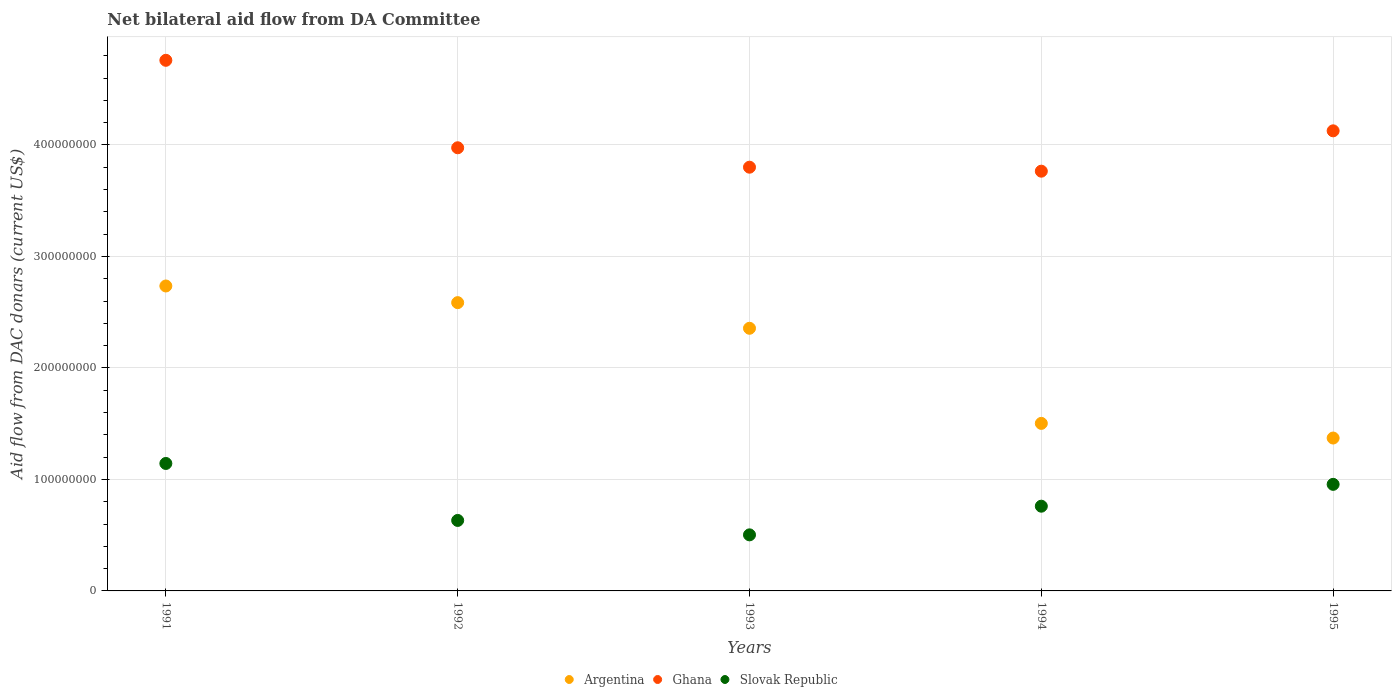What is the aid flow in in Slovak Republic in 1995?
Offer a terse response. 9.56e+07. Across all years, what is the maximum aid flow in in Argentina?
Offer a terse response. 2.74e+08. Across all years, what is the minimum aid flow in in Slovak Republic?
Give a very brief answer. 5.03e+07. In which year was the aid flow in in Ghana minimum?
Offer a very short reply. 1994. What is the total aid flow in in Ghana in the graph?
Give a very brief answer. 2.04e+09. What is the difference between the aid flow in in Argentina in 1991 and that in 1992?
Give a very brief answer. 1.49e+07. What is the difference between the aid flow in in Slovak Republic in 1991 and the aid flow in in Ghana in 1995?
Your response must be concise. -2.98e+08. What is the average aid flow in in Slovak Republic per year?
Offer a terse response. 7.99e+07. In the year 1991, what is the difference between the aid flow in in Ghana and aid flow in in Argentina?
Your response must be concise. 2.02e+08. In how many years, is the aid flow in in Ghana greater than 80000000 US$?
Ensure brevity in your answer.  5. What is the ratio of the aid flow in in Ghana in 1994 to that in 1995?
Your answer should be very brief. 0.91. Is the aid flow in in Argentina in 1993 less than that in 1995?
Offer a terse response. No. Is the difference between the aid flow in in Ghana in 1992 and 1995 greater than the difference between the aid flow in in Argentina in 1992 and 1995?
Ensure brevity in your answer.  No. What is the difference between the highest and the second highest aid flow in in Ghana?
Provide a succinct answer. 6.33e+07. What is the difference between the highest and the lowest aid flow in in Ghana?
Offer a very short reply. 9.94e+07. In how many years, is the aid flow in in Slovak Republic greater than the average aid flow in in Slovak Republic taken over all years?
Your answer should be very brief. 2. Is the sum of the aid flow in in Slovak Republic in 1991 and 1995 greater than the maximum aid flow in in Ghana across all years?
Make the answer very short. No. Is it the case that in every year, the sum of the aid flow in in Argentina and aid flow in in Ghana  is greater than the aid flow in in Slovak Republic?
Your answer should be compact. Yes. Does the aid flow in in Argentina monotonically increase over the years?
Make the answer very short. No. Is the aid flow in in Argentina strictly greater than the aid flow in in Ghana over the years?
Your response must be concise. No. Are the values on the major ticks of Y-axis written in scientific E-notation?
Make the answer very short. No. Does the graph contain any zero values?
Your response must be concise. No. How many legend labels are there?
Your answer should be very brief. 3. How are the legend labels stacked?
Your answer should be very brief. Horizontal. What is the title of the graph?
Offer a very short reply. Net bilateral aid flow from DA Committee. Does "Lithuania" appear as one of the legend labels in the graph?
Keep it short and to the point. No. What is the label or title of the Y-axis?
Provide a succinct answer. Aid flow from DAC donars (current US$). What is the Aid flow from DAC donars (current US$) of Argentina in 1991?
Make the answer very short. 2.74e+08. What is the Aid flow from DAC donars (current US$) in Ghana in 1991?
Your response must be concise. 4.76e+08. What is the Aid flow from DAC donars (current US$) of Slovak Republic in 1991?
Give a very brief answer. 1.14e+08. What is the Aid flow from DAC donars (current US$) in Argentina in 1992?
Your answer should be very brief. 2.59e+08. What is the Aid flow from DAC donars (current US$) of Ghana in 1992?
Your answer should be very brief. 3.97e+08. What is the Aid flow from DAC donars (current US$) in Slovak Republic in 1992?
Your response must be concise. 6.32e+07. What is the Aid flow from DAC donars (current US$) in Argentina in 1993?
Ensure brevity in your answer.  2.36e+08. What is the Aid flow from DAC donars (current US$) in Ghana in 1993?
Offer a terse response. 3.80e+08. What is the Aid flow from DAC donars (current US$) in Slovak Republic in 1993?
Ensure brevity in your answer.  5.03e+07. What is the Aid flow from DAC donars (current US$) of Argentina in 1994?
Provide a short and direct response. 1.50e+08. What is the Aid flow from DAC donars (current US$) in Ghana in 1994?
Your response must be concise. 3.76e+08. What is the Aid flow from DAC donars (current US$) of Slovak Republic in 1994?
Provide a short and direct response. 7.60e+07. What is the Aid flow from DAC donars (current US$) in Argentina in 1995?
Offer a very short reply. 1.37e+08. What is the Aid flow from DAC donars (current US$) of Ghana in 1995?
Make the answer very short. 4.13e+08. What is the Aid flow from DAC donars (current US$) of Slovak Republic in 1995?
Your response must be concise. 9.56e+07. Across all years, what is the maximum Aid flow from DAC donars (current US$) of Argentina?
Ensure brevity in your answer.  2.74e+08. Across all years, what is the maximum Aid flow from DAC donars (current US$) of Ghana?
Keep it short and to the point. 4.76e+08. Across all years, what is the maximum Aid flow from DAC donars (current US$) in Slovak Republic?
Ensure brevity in your answer.  1.14e+08. Across all years, what is the minimum Aid flow from DAC donars (current US$) in Argentina?
Ensure brevity in your answer.  1.37e+08. Across all years, what is the minimum Aid flow from DAC donars (current US$) in Ghana?
Provide a succinct answer. 3.76e+08. Across all years, what is the minimum Aid flow from DAC donars (current US$) in Slovak Republic?
Keep it short and to the point. 5.03e+07. What is the total Aid flow from DAC donars (current US$) of Argentina in the graph?
Your response must be concise. 1.06e+09. What is the total Aid flow from DAC donars (current US$) in Ghana in the graph?
Provide a short and direct response. 2.04e+09. What is the total Aid flow from DAC donars (current US$) of Slovak Republic in the graph?
Your response must be concise. 3.99e+08. What is the difference between the Aid flow from DAC donars (current US$) of Argentina in 1991 and that in 1992?
Make the answer very short. 1.49e+07. What is the difference between the Aid flow from DAC donars (current US$) of Ghana in 1991 and that in 1992?
Provide a short and direct response. 7.84e+07. What is the difference between the Aid flow from DAC donars (current US$) of Slovak Republic in 1991 and that in 1992?
Provide a succinct answer. 5.11e+07. What is the difference between the Aid flow from DAC donars (current US$) in Argentina in 1991 and that in 1993?
Offer a terse response. 3.79e+07. What is the difference between the Aid flow from DAC donars (current US$) of Ghana in 1991 and that in 1993?
Offer a terse response. 9.59e+07. What is the difference between the Aid flow from DAC donars (current US$) of Slovak Republic in 1991 and that in 1993?
Give a very brief answer. 6.40e+07. What is the difference between the Aid flow from DAC donars (current US$) of Argentina in 1991 and that in 1994?
Provide a succinct answer. 1.23e+08. What is the difference between the Aid flow from DAC donars (current US$) in Ghana in 1991 and that in 1994?
Your answer should be very brief. 9.94e+07. What is the difference between the Aid flow from DAC donars (current US$) in Slovak Republic in 1991 and that in 1994?
Your response must be concise. 3.83e+07. What is the difference between the Aid flow from DAC donars (current US$) in Argentina in 1991 and that in 1995?
Provide a succinct answer. 1.36e+08. What is the difference between the Aid flow from DAC donars (current US$) of Ghana in 1991 and that in 1995?
Offer a terse response. 6.33e+07. What is the difference between the Aid flow from DAC donars (current US$) of Slovak Republic in 1991 and that in 1995?
Offer a terse response. 1.87e+07. What is the difference between the Aid flow from DAC donars (current US$) of Argentina in 1992 and that in 1993?
Ensure brevity in your answer.  2.30e+07. What is the difference between the Aid flow from DAC donars (current US$) in Ghana in 1992 and that in 1993?
Provide a short and direct response. 1.74e+07. What is the difference between the Aid flow from DAC donars (current US$) in Slovak Republic in 1992 and that in 1993?
Offer a very short reply. 1.29e+07. What is the difference between the Aid flow from DAC donars (current US$) of Argentina in 1992 and that in 1994?
Offer a very short reply. 1.08e+08. What is the difference between the Aid flow from DAC donars (current US$) in Ghana in 1992 and that in 1994?
Provide a succinct answer. 2.10e+07. What is the difference between the Aid flow from DAC donars (current US$) of Slovak Republic in 1992 and that in 1994?
Give a very brief answer. -1.28e+07. What is the difference between the Aid flow from DAC donars (current US$) of Argentina in 1992 and that in 1995?
Give a very brief answer. 1.21e+08. What is the difference between the Aid flow from DAC donars (current US$) of Ghana in 1992 and that in 1995?
Ensure brevity in your answer.  -1.52e+07. What is the difference between the Aid flow from DAC donars (current US$) in Slovak Republic in 1992 and that in 1995?
Make the answer very short. -3.24e+07. What is the difference between the Aid flow from DAC donars (current US$) of Argentina in 1993 and that in 1994?
Ensure brevity in your answer.  8.53e+07. What is the difference between the Aid flow from DAC donars (current US$) in Ghana in 1993 and that in 1994?
Offer a very short reply. 3.57e+06. What is the difference between the Aid flow from DAC donars (current US$) of Slovak Republic in 1993 and that in 1994?
Your answer should be compact. -2.57e+07. What is the difference between the Aid flow from DAC donars (current US$) in Argentina in 1993 and that in 1995?
Offer a terse response. 9.84e+07. What is the difference between the Aid flow from DAC donars (current US$) of Ghana in 1993 and that in 1995?
Your answer should be compact. -3.26e+07. What is the difference between the Aid flow from DAC donars (current US$) of Slovak Republic in 1993 and that in 1995?
Keep it short and to the point. -4.53e+07. What is the difference between the Aid flow from DAC donars (current US$) in Argentina in 1994 and that in 1995?
Provide a short and direct response. 1.31e+07. What is the difference between the Aid flow from DAC donars (current US$) in Ghana in 1994 and that in 1995?
Make the answer very short. -3.62e+07. What is the difference between the Aid flow from DAC donars (current US$) in Slovak Republic in 1994 and that in 1995?
Your answer should be very brief. -1.96e+07. What is the difference between the Aid flow from DAC donars (current US$) in Argentina in 1991 and the Aid flow from DAC donars (current US$) in Ghana in 1992?
Provide a succinct answer. -1.24e+08. What is the difference between the Aid flow from DAC donars (current US$) in Argentina in 1991 and the Aid flow from DAC donars (current US$) in Slovak Republic in 1992?
Your answer should be compact. 2.10e+08. What is the difference between the Aid flow from DAC donars (current US$) of Ghana in 1991 and the Aid flow from DAC donars (current US$) of Slovak Republic in 1992?
Your answer should be very brief. 4.13e+08. What is the difference between the Aid flow from DAC donars (current US$) of Argentina in 1991 and the Aid flow from DAC donars (current US$) of Ghana in 1993?
Give a very brief answer. -1.07e+08. What is the difference between the Aid flow from DAC donars (current US$) of Argentina in 1991 and the Aid flow from DAC donars (current US$) of Slovak Republic in 1993?
Provide a short and direct response. 2.23e+08. What is the difference between the Aid flow from DAC donars (current US$) of Ghana in 1991 and the Aid flow from DAC donars (current US$) of Slovak Republic in 1993?
Your answer should be very brief. 4.26e+08. What is the difference between the Aid flow from DAC donars (current US$) in Argentina in 1991 and the Aid flow from DAC donars (current US$) in Ghana in 1994?
Ensure brevity in your answer.  -1.03e+08. What is the difference between the Aid flow from DAC donars (current US$) in Argentina in 1991 and the Aid flow from DAC donars (current US$) in Slovak Republic in 1994?
Give a very brief answer. 1.98e+08. What is the difference between the Aid flow from DAC donars (current US$) in Ghana in 1991 and the Aid flow from DAC donars (current US$) in Slovak Republic in 1994?
Keep it short and to the point. 4.00e+08. What is the difference between the Aid flow from DAC donars (current US$) in Argentina in 1991 and the Aid flow from DAC donars (current US$) in Ghana in 1995?
Your answer should be compact. -1.39e+08. What is the difference between the Aid flow from DAC donars (current US$) of Argentina in 1991 and the Aid flow from DAC donars (current US$) of Slovak Republic in 1995?
Your answer should be very brief. 1.78e+08. What is the difference between the Aid flow from DAC donars (current US$) of Ghana in 1991 and the Aid flow from DAC donars (current US$) of Slovak Republic in 1995?
Your answer should be compact. 3.80e+08. What is the difference between the Aid flow from DAC donars (current US$) of Argentina in 1992 and the Aid flow from DAC donars (current US$) of Ghana in 1993?
Your answer should be compact. -1.21e+08. What is the difference between the Aid flow from DAC donars (current US$) in Argentina in 1992 and the Aid flow from DAC donars (current US$) in Slovak Republic in 1993?
Your answer should be compact. 2.08e+08. What is the difference between the Aid flow from DAC donars (current US$) of Ghana in 1992 and the Aid flow from DAC donars (current US$) of Slovak Republic in 1993?
Offer a terse response. 3.47e+08. What is the difference between the Aid flow from DAC donars (current US$) of Argentina in 1992 and the Aid flow from DAC donars (current US$) of Ghana in 1994?
Provide a short and direct response. -1.18e+08. What is the difference between the Aid flow from DAC donars (current US$) of Argentina in 1992 and the Aid flow from DAC donars (current US$) of Slovak Republic in 1994?
Your answer should be compact. 1.83e+08. What is the difference between the Aid flow from DAC donars (current US$) in Ghana in 1992 and the Aid flow from DAC donars (current US$) in Slovak Republic in 1994?
Your answer should be very brief. 3.21e+08. What is the difference between the Aid flow from DAC donars (current US$) in Argentina in 1992 and the Aid flow from DAC donars (current US$) in Ghana in 1995?
Offer a very short reply. -1.54e+08. What is the difference between the Aid flow from DAC donars (current US$) in Argentina in 1992 and the Aid flow from DAC donars (current US$) in Slovak Republic in 1995?
Your answer should be very brief. 1.63e+08. What is the difference between the Aid flow from DAC donars (current US$) of Ghana in 1992 and the Aid flow from DAC donars (current US$) of Slovak Republic in 1995?
Offer a terse response. 3.02e+08. What is the difference between the Aid flow from DAC donars (current US$) of Argentina in 1993 and the Aid flow from DAC donars (current US$) of Ghana in 1994?
Ensure brevity in your answer.  -1.41e+08. What is the difference between the Aid flow from DAC donars (current US$) of Argentina in 1993 and the Aid flow from DAC donars (current US$) of Slovak Republic in 1994?
Your answer should be compact. 1.60e+08. What is the difference between the Aid flow from DAC donars (current US$) of Ghana in 1993 and the Aid flow from DAC donars (current US$) of Slovak Republic in 1994?
Keep it short and to the point. 3.04e+08. What is the difference between the Aid flow from DAC donars (current US$) of Argentina in 1993 and the Aid flow from DAC donars (current US$) of Ghana in 1995?
Offer a terse response. -1.77e+08. What is the difference between the Aid flow from DAC donars (current US$) of Argentina in 1993 and the Aid flow from DAC donars (current US$) of Slovak Republic in 1995?
Provide a succinct answer. 1.40e+08. What is the difference between the Aid flow from DAC donars (current US$) in Ghana in 1993 and the Aid flow from DAC donars (current US$) in Slovak Republic in 1995?
Offer a very short reply. 2.84e+08. What is the difference between the Aid flow from DAC donars (current US$) in Argentina in 1994 and the Aid flow from DAC donars (current US$) in Ghana in 1995?
Your answer should be compact. -2.62e+08. What is the difference between the Aid flow from DAC donars (current US$) of Argentina in 1994 and the Aid flow from DAC donars (current US$) of Slovak Republic in 1995?
Ensure brevity in your answer.  5.47e+07. What is the difference between the Aid flow from DAC donars (current US$) of Ghana in 1994 and the Aid flow from DAC donars (current US$) of Slovak Republic in 1995?
Keep it short and to the point. 2.81e+08. What is the average Aid flow from DAC donars (current US$) in Argentina per year?
Give a very brief answer. 2.11e+08. What is the average Aid flow from DAC donars (current US$) of Ghana per year?
Offer a very short reply. 4.09e+08. What is the average Aid flow from DAC donars (current US$) in Slovak Republic per year?
Make the answer very short. 7.99e+07. In the year 1991, what is the difference between the Aid flow from DAC donars (current US$) of Argentina and Aid flow from DAC donars (current US$) of Ghana?
Offer a very short reply. -2.02e+08. In the year 1991, what is the difference between the Aid flow from DAC donars (current US$) of Argentina and Aid flow from DAC donars (current US$) of Slovak Republic?
Your response must be concise. 1.59e+08. In the year 1991, what is the difference between the Aid flow from DAC donars (current US$) in Ghana and Aid flow from DAC donars (current US$) in Slovak Republic?
Make the answer very short. 3.62e+08. In the year 1992, what is the difference between the Aid flow from DAC donars (current US$) of Argentina and Aid flow from DAC donars (current US$) of Ghana?
Provide a short and direct response. -1.39e+08. In the year 1992, what is the difference between the Aid flow from DAC donars (current US$) of Argentina and Aid flow from DAC donars (current US$) of Slovak Republic?
Give a very brief answer. 1.95e+08. In the year 1992, what is the difference between the Aid flow from DAC donars (current US$) of Ghana and Aid flow from DAC donars (current US$) of Slovak Republic?
Offer a terse response. 3.34e+08. In the year 1993, what is the difference between the Aid flow from DAC donars (current US$) of Argentina and Aid flow from DAC donars (current US$) of Ghana?
Provide a succinct answer. -1.44e+08. In the year 1993, what is the difference between the Aid flow from DAC donars (current US$) of Argentina and Aid flow from DAC donars (current US$) of Slovak Republic?
Ensure brevity in your answer.  1.85e+08. In the year 1993, what is the difference between the Aid flow from DAC donars (current US$) of Ghana and Aid flow from DAC donars (current US$) of Slovak Republic?
Your answer should be very brief. 3.30e+08. In the year 1994, what is the difference between the Aid flow from DAC donars (current US$) in Argentina and Aid flow from DAC donars (current US$) in Ghana?
Make the answer very short. -2.26e+08. In the year 1994, what is the difference between the Aid flow from DAC donars (current US$) in Argentina and Aid flow from DAC donars (current US$) in Slovak Republic?
Your answer should be very brief. 7.43e+07. In the year 1994, what is the difference between the Aid flow from DAC donars (current US$) of Ghana and Aid flow from DAC donars (current US$) of Slovak Republic?
Make the answer very short. 3.00e+08. In the year 1995, what is the difference between the Aid flow from DAC donars (current US$) in Argentina and Aid flow from DAC donars (current US$) in Ghana?
Keep it short and to the point. -2.76e+08. In the year 1995, what is the difference between the Aid flow from DAC donars (current US$) in Argentina and Aid flow from DAC donars (current US$) in Slovak Republic?
Offer a very short reply. 4.15e+07. In the year 1995, what is the difference between the Aid flow from DAC donars (current US$) of Ghana and Aid flow from DAC donars (current US$) of Slovak Republic?
Make the answer very short. 3.17e+08. What is the ratio of the Aid flow from DAC donars (current US$) of Argentina in 1991 to that in 1992?
Give a very brief answer. 1.06. What is the ratio of the Aid flow from DAC donars (current US$) in Ghana in 1991 to that in 1992?
Offer a terse response. 1.2. What is the ratio of the Aid flow from DAC donars (current US$) in Slovak Republic in 1991 to that in 1992?
Give a very brief answer. 1.81. What is the ratio of the Aid flow from DAC donars (current US$) in Argentina in 1991 to that in 1993?
Ensure brevity in your answer.  1.16. What is the ratio of the Aid flow from DAC donars (current US$) in Ghana in 1991 to that in 1993?
Provide a short and direct response. 1.25. What is the ratio of the Aid flow from DAC donars (current US$) of Slovak Republic in 1991 to that in 1993?
Give a very brief answer. 2.27. What is the ratio of the Aid flow from DAC donars (current US$) of Argentina in 1991 to that in 1994?
Offer a terse response. 1.82. What is the ratio of the Aid flow from DAC donars (current US$) in Ghana in 1991 to that in 1994?
Offer a terse response. 1.26. What is the ratio of the Aid flow from DAC donars (current US$) in Slovak Republic in 1991 to that in 1994?
Provide a short and direct response. 1.5. What is the ratio of the Aid flow from DAC donars (current US$) in Argentina in 1991 to that in 1995?
Offer a terse response. 1.99. What is the ratio of the Aid flow from DAC donars (current US$) in Ghana in 1991 to that in 1995?
Make the answer very short. 1.15. What is the ratio of the Aid flow from DAC donars (current US$) in Slovak Republic in 1991 to that in 1995?
Provide a succinct answer. 1.2. What is the ratio of the Aid flow from DAC donars (current US$) in Argentina in 1992 to that in 1993?
Offer a very short reply. 1.1. What is the ratio of the Aid flow from DAC donars (current US$) of Ghana in 1992 to that in 1993?
Your answer should be compact. 1.05. What is the ratio of the Aid flow from DAC donars (current US$) in Slovak Republic in 1992 to that in 1993?
Provide a short and direct response. 1.26. What is the ratio of the Aid flow from DAC donars (current US$) of Argentina in 1992 to that in 1994?
Your answer should be compact. 1.72. What is the ratio of the Aid flow from DAC donars (current US$) in Ghana in 1992 to that in 1994?
Your response must be concise. 1.06. What is the ratio of the Aid flow from DAC donars (current US$) in Slovak Republic in 1992 to that in 1994?
Provide a short and direct response. 0.83. What is the ratio of the Aid flow from DAC donars (current US$) of Argentina in 1992 to that in 1995?
Your answer should be very brief. 1.89. What is the ratio of the Aid flow from DAC donars (current US$) of Ghana in 1992 to that in 1995?
Give a very brief answer. 0.96. What is the ratio of the Aid flow from DAC donars (current US$) in Slovak Republic in 1992 to that in 1995?
Provide a short and direct response. 0.66. What is the ratio of the Aid flow from DAC donars (current US$) in Argentina in 1993 to that in 1994?
Your response must be concise. 1.57. What is the ratio of the Aid flow from DAC donars (current US$) of Ghana in 1993 to that in 1994?
Offer a terse response. 1.01. What is the ratio of the Aid flow from DAC donars (current US$) of Slovak Republic in 1993 to that in 1994?
Your answer should be compact. 0.66. What is the ratio of the Aid flow from DAC donars (current US$) in Argentina in 1993 to that in 1995?
Your answer should be compact. 1.72. What is the ratio of the Aid flow from DAC donars (current US$) of Ghana in 1993 to that in 1995?
Provide a succinct answer. 0.92. What is the ratio of the Aid flow from DAC donars (current US$) in Slovak Republic in 1993 to that in 1995?
Give a very brief answer. 0.53. What is the ratio of the Aid flow from DAC donars (current US$) in Argentina in 1994 to that in 1995?
Make the answer very short. 1.1. What is the ratio of the Aid flow from DAC donars (current US$) of Ghana in 1994 to that in 1995?
Make the answer very short. 0.91. What is the ratio of the Aid flow from DAC donars (current US$) of Slovak Republic in 1994 to that in 1995?
Your response must be concise. 0.8. What is the difference between the highest and the second highest Aid flow from DAC donars (current US$) in Argentina?
Make the answer very short. 1.49e+07. What is the difference between the highest and the second highest Aid flow from DAC donars (current US$) of Ghana?
Keep it short and to the point. 6.33e+07. What is the difference between the highest and the second highest Aid flow from DAC donars (current US$) of Slovak Republic?
Your response must be concise. 1.87e+07. What is the difference between the highest and the lowest Aid flow from DAC donars (current US$) of Argentina?
Your answer should be compact. 1.36e+08. What is the difference between the highest and the lowest Aid flow from DAC donars (current US$) in Ghana?
Your response must be concise. 9.94e+07. What is the difference between the highest and the lowest Aid flow from DAC donars (current US$) in Slovak Republic?
Offer a very short reply. 6.40e+07. 